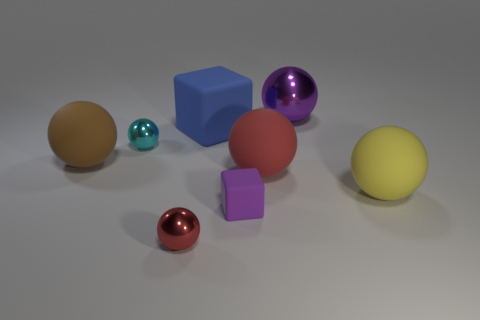The yellow thing that is made of the same material as the large cube is what size?
Make the answer very short. Large. What number of small metal objects have the same color as the small rubber block?
Your answer should be very brief. 0. Do the purple object that is in front of the purple metal object and the big blue matte block have the same size?
Your answer should be very brief. No. The shiny thing that is behind the tiny red object and to the left of the large purple metallic object is what color?
Provide a succinct answer. Cyan. How many objects are either tiny purple objects or big rubber objects that are left of the large purple object?
Your response must be concise. 4. What material is the thing that is to the right of the big metal sphere that is on the right side of the rubber cube that is on the right side of the large rubber block?
Make the answer very short. Rubber. Is there any other thing that is the same material as the large brown object?
Ensure brevity in your answer.  Yes. There is a rubber object that is left of the large rubber block; is its color the same as the large metallic thing?
Your answer should be compact. No. What number of purple things are blocks or matte objects?
Offer a very short reply. 1. What number of other things are there of the same shape as the yellow object?
Provide a succinct answer. 5. 